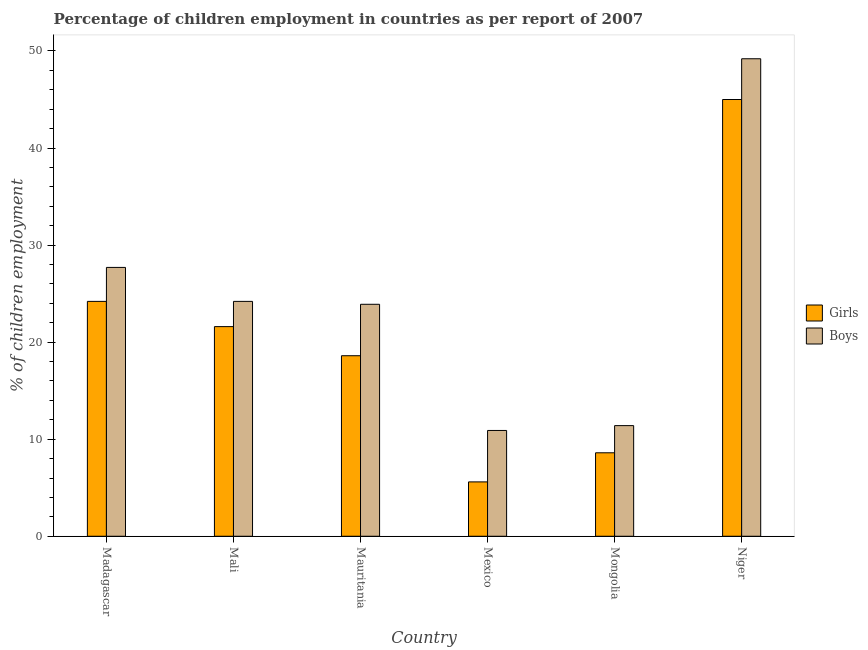Are the number of bars per tick equal to the number of legend labels?
Your answer should be very brief. Yes. Are the number of bars on each tick of the X-axis equal?
Your response must be concise. Yes. How many bars are there on the 5th tick from the left?
Make the answer very short. 2. What is the label of the 3rd group of bars from the left?
Your answer should be very brief. Mauritania. In how many cases, is the number of bars for a given country not equal to the number of legend labels?
Your response must be concise. 0. What is the percentage of employed boys in Mongolia?
Keep it short and to the point. 11.4. Across all countries, what is the maximum percentage of employed girls?
Ensure brevity in your answer.  45. In which country was the percentage of employed boys maximum?
Your answer should be compact. Niger. In which country was the percentage of employed boys minimum?
Your answer should be very brief. Mexico. What is the total percentage of employed girls in the graph?
Make the answer very short. 123.6. What is the difference between the percentage of employed boys in Mali and that in Niger?
Provide a succinct answer. -25. What is the average percentage of employed girls per country?
Give a very brief answer. 20.6. What is the difference between the percentage of employed girls and percentage of employed boys in Mali?
Make the answer very short. -2.6. What is the ratio of the percentage of employed girls in Madagascar to that in Niger?
Give a very brief answer. 0.54. Is the difference between the percentage of employed girls in Madagascar and Mali greater than the difference between the percentage of employed boys in Madagascar and Mali?
Ensure brevity in your answer.  No. What is the difference between the highest and the second highest percentage of employed girls?
Provide a succinct answer. 20.8. What is the difference between the highest and the lowest percentage of employed girls?
Offer a terse response. 39.4. In how many countries, is the percentage of employed girls greater than the average percentage of employed girls taken over all countries?
Your answer should be very brief. 3. Is the sum of the percentage of employed girls in Mauritania and Mexico greater than the maximum percentage of employed boys across all countries?
Your answer should be very brief. No. What does the 1st bar from the left in Mexico represents?
Give a very brief answer. Girls. What does the 1st bar from the right in Madagascar represents?
Offer a very short reply. Boys. How many bars are there?
Provide a short and direct response. 12. How many countries are there in the graph?
Provide a short and direct response. 6. What is the difference between two consecutive major ticks on the Y-axis?
Your answer should be very brief. 10. Does the graph contain any zero values?
Give a very brief answer. No. Does the graph contain grids?
Your response must be concise. No. Where does the legend appear in the graph?
Make the answer very short. Center right. What is the title of the graph?
Keep it short and to the point. Percentage of children employment in countries as per report of 2007. Does "Enforce a contract" appear as one of the legend labels in the graph?
Offer a terse response. No. What is the label or title of the X-axis?
Ensure brevity in your answer.  Country. What is the label or title of the Y-axis?
Give a very brief answer. % of children employment. What is the % of children employment in Girls in Madagascar?
Provide a succinct answer. 24.2. What is the % of children employment of Boys in Madagascar?
Give a very brief answer. 27.7. What is the % of children employment of Girls in Mali?
Provide a short and direct response. 21.6. What is the % of children employment of Boys in Mali?
Provide a succinct answer. 24.2. What is the % of children employment of Boys in Mauritania?
Make the answer very short. 23.9. What is the % of children employment in Girls in Mexico?
Ensure brevity in your answer.  5.6. What is the % of children employment of Boys in Mexico?
Keep it short and to the point. 10.9. What is the % of children employment of Boys in Niger?
Provide a short and direct response. 49.2. Across all countries, what is the maximum % of children employment of Boys?
Offer a terse response. 49.2. Across all countries, what is the minimum % of children employment in Boys?
Provide a succinct answer. 10.9. What is the total % of children employment in Girls in the graph?
Ensure brevity in your answer.  123.6. What is the total % of children employment in Boys in the graph?
Offer a very short reply. 147.3. What is the difference between the % of children employment in Girls in Madagascar and that in Mali?
Your answer should be very brief. 2.6. What is the difference between the % of children employment of Girls in Madagascar and that in Niger?
Your response must be concise. -20.8. What is the difference between the % of children employment of Boys in Madagascar and that in Niger?
Keep it short and to the point. -21.5. What is the difference between the % of children employment in Boys in Mali and that in Mauritania?
Make the answer very short. 0.3. What is the difference between the % of children employment of Girls in Mali and that in Mongolia?
Make the answer very short. 13. What is the difference between the % of children employment in Girls in Mali and that in Niger?
Provide a short and direct response. -23.4. What is the difference between the % of children employment of Boys in Mali and that in Niger?
Your answer should be compact. -25. What is the difference between the % of children employment in Girls in Mauritania and that in Mexico?
Your answer should be compact. 13. What is the difference between the % of children employment in Girls in Mauritania and that in Mongolia?
Your answer should be very brief. 10. What is the difference between the % of children employment in Boys in Mauritania and that in Mongolia?
Keep it short and to the point. 12.5. What is the difference between the % of children employment of Girls in Mauritania and that in Niger?
Provide a short and direct response. -26.4. What is the difference between the % of children employment in Boys in Mauritania and that in Niger?
Keep it short and to the point. -25.3. What is the difference between the % of children employment in Girls in Mexico and that in Niger?
Provide a succinct answer. -39.4. What is the difference between the % of children employment in Boys in Mexico and that in Niger?
Keep it short and to the point. -38.3. What is the difference between the % of children employment of Girls in Mongolia and that in Niger?
Keep it short and to the point. -36.4. What is the difference between the % of children employment of Boys in Mongolia and that in Niger?
Provide a succinct answer. -37.8. What is the difference between the % of children employment in Girls in Madagascar and the % of children employment in Boys in Mali?
Offer a terse response. 0. What is the difference between the % of children employment of Girls in Madagascar and the % of children employment of Boys in Mauritania?
Provide a succinct answer. 0.3. What is the difference between the % of children employment in Girls in Mali and the % of children employment in Boys in Mauritania?
Your answer should be very brief. -2.3. What is the difference between the % of children employment of Girls in Mali and the % of children employment of Boys in Mexico?
Provide a short and direct response. 10.7. What is the difference between the % of children employment of Girls in Mali and the % of children employment of Boys in Mongolia?
Give a very brief answer. 10.2. What is the difference between the % of children employment in Girls in Mali and the % of children employment in Boys in Niger?
Your answer should be compact. -27.6. What is the difference between the % of children employment of Girls in Mauritania and the % of children employment of Boys in Niger?
Keep it short and to the point. -30.6. What is the difference between the % of children employment in Girls in Mexico and the % of children employment in Boys in Mongolia?
Provide a short and direct response. -5.8. What is the difference between the % of children employment of Girls in Mexico and the % of children employment of Boys in Niger?
Make the answer very short. -43.6. What is the difference between the % of children employment in Girls in Mongolia and the % of children employment in Boys in Niger?
Offer a terse response. -40.6. What is the average % of children employment of Girls per country?
Provide a succinct answer. 20.6. What is the average % of children employment in Boys per country?
Your answer should be compact. 24.55. What is the difference between the % of children employment in Girls and % of children employment in Boys in Mali?
Offer a very short reply. -2.6. What is the difference between the % of children employment in Girls and % of children employment in Boys in Mongolia?
Ensure brevity in your answer.  -2.8. What is the ratio of the % of children employment of Girls in Madagascar to that in Mali?
Keep it short and to the point. 1.12. What is the ratio of the % of children employment of Boys in Madagascar to that in Mali?
Offer a terse response. 1.14. What is the ratio of the % of children employment in Girls in Madagascar to that in Mauritania?
Offer a terse response. 1.3. What is the ratio of the % of children employment in Boys in Madagascar to that in Mauritania?
Offer a very short reply. 1.16. What is the ratio of the % of children employment in Girls in Madagascar to that in Mexico?
Ensure brevity in your answer.  4.32. What is the ratio of the % of children employment in Boys in Madagascar to that in Mexico?
Provide a succinct answer. 2.54. What is the ratio of the % of children employment in Girls in Madagascar to that in Mongolia?
Your response must be concise. 2.81. What is the ratio of the % of children employment in Boys in Madagascar to that in Mongolia?
Give a very brief answer. 2.43. What is the ratio of the % of children employment of Girls in Madagascar to that in Niger?
Your response must be concise. 0.54. What is the ratio of the % of children employment in Boys in Madagascar to that in Niger?
Provide a short and direct response. 0.56. What is the ratio of the % of children employment in Girls in Mali to that in Mauritania?
Keep it short and to the point. 1.16. What is the ratio of the % of children employment of Boys in Mali to that in Mauritania?
Offer a terse response. 1.01. What is the ratio of the % of children employment of Girls in Mali to that in Mexico?
Your answer should be very brief. 3.86. What is the ratio of the % of children employment in Boys in Mali to that in Mexico?
Offer a very short reply. 2.22. What is the ratio of the % of children employment of Girls in Mali to that in Mongolia?
Your answer should be compact. 2.51. What is the ratio of the % of children employment of Boys in Mali to that in Mongolia?
Offer a terse response. 2.12. What is the ratio of the % of children employment of Girls in Mali to that in Niger?
Offer a very short reply. 0.48. What is the ratio of the % of children employment of Boys in Mali to that in Niger?
Provide a short and direct response. 0.49. What is the ratio of the % of children employment of Girls in Mauritania to that in Mexico?
Keep it short and to the point. 3.32. What is the ratio of the % of children employment of Boys in Mauritania to that in Mexico?
Give a very brief answer. 2.19. What is the ratio of the % of children employment of Girls in Mauritania to that in Mongolia?
Provide a succinct answer. 2.16. What is the ratio of the % of children employment of Boys in Mauritania to that in Mongolia?
Offer a very short reply. 2.1. What is the ratio of the % of children employment of Girls in Mauritania to that in Niger?
Your response must be concise. 0.41. What is the ratio of the % of children employment in Boys in Mauritania to that in Niger?
Ensure brevity in your answer.  0.49. What is the ratio of the % of children employment in Girls in Mexico to that in Mongolia?
Make the answer very short. 0.65. What is the ratio of the % of children employment in Boys in Mexico to that in Mongolia?
Your answer should be compact. 0.96. What is the ratio of the % of children employment of Girls in Mexico to that in Niger?
Your response must be concise. 0.12. What is the ratio of the % of children employment in Boys in Mexico to that in Niger?
Give a very brief answer. 0.22. What is the ratio of the % of children employment in Girls in Mongolia to that in Niger?
Give a very brief answer. 0.19. What is the ratio of the % of children employment of Boys in Mongolia to that in Niger?
Your answer should be compact. 0.23. What is the difference between the highest and the second highest % of children employment in Girls?
Keep it short and to the point. 20.8. What is the difference between the highest and the second highest % of children employment of Boys?
Ensure brevity in your answer.  21.5. What is the difference between the highest and the lowest % of children employment of Girls?
Ensure brevity in your answer.  39.4. What is the difference between the highest and the lowest % of children employment of Boys?
Give a very brief answer. 38.3. 